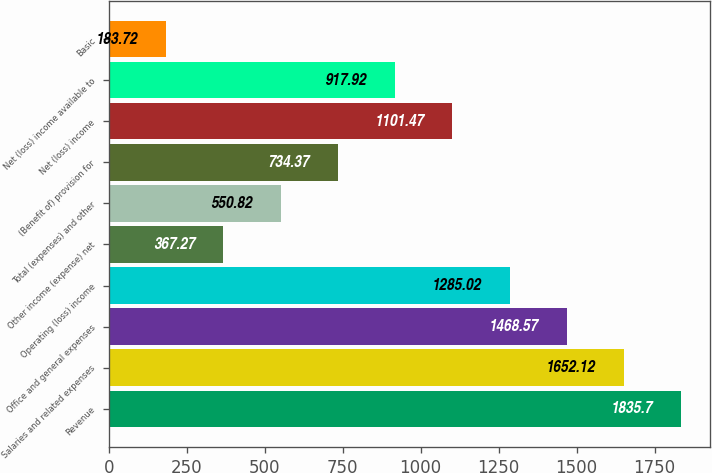<chart> <loc_0><loc_0><loc_500><loc_500><bar_chart><fcel>Revenue<fcel>Salaries and related expenses<fcel>Office and general expenses<fcel>Operating (loss) income<fcel>Other income (expense) net<fcel>Total (expenses) and other<fcel>(Benefit of) provision for<fcel>Net (loss) income<fcel>Net (loss) income available to<fcel>Basic<nl><fcel>1835.7<fcel>1652.12<fcel>1468.57<fcel>1285.02<fcel>367.27<fcel>550.82<fcel>734.37<fcel>1101.47<fcel>917.92<fcel>183.72<nl></chart> 